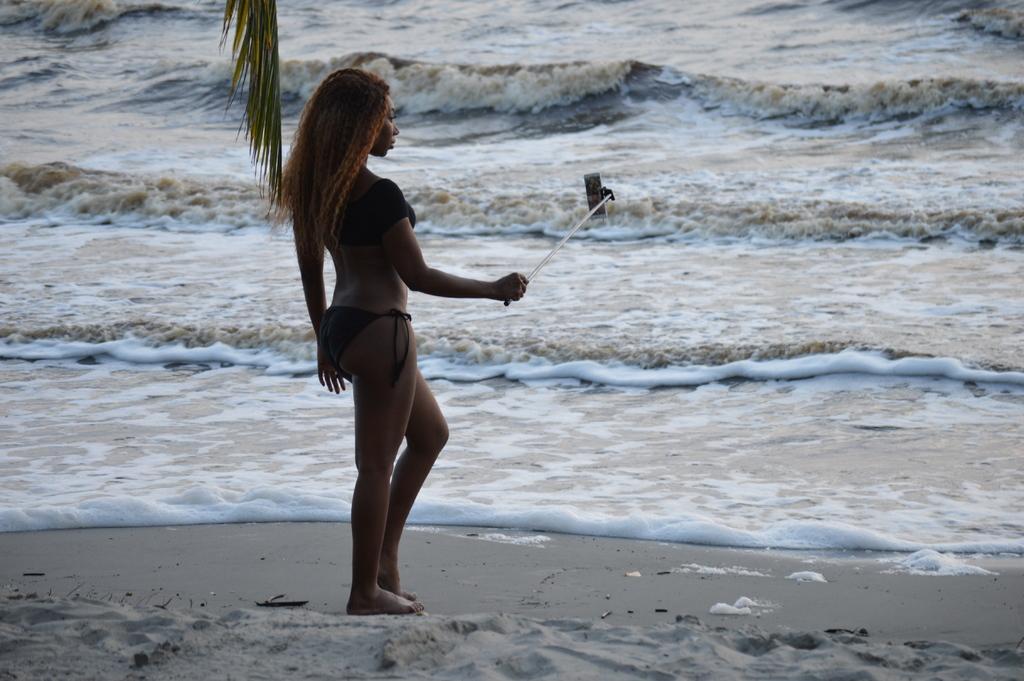Please provide a concise description of this image. Here we can see a woman standing on the sand by holding a selfie stick in her hand. In the background we can see water and there is a branch of a tree at the top. 